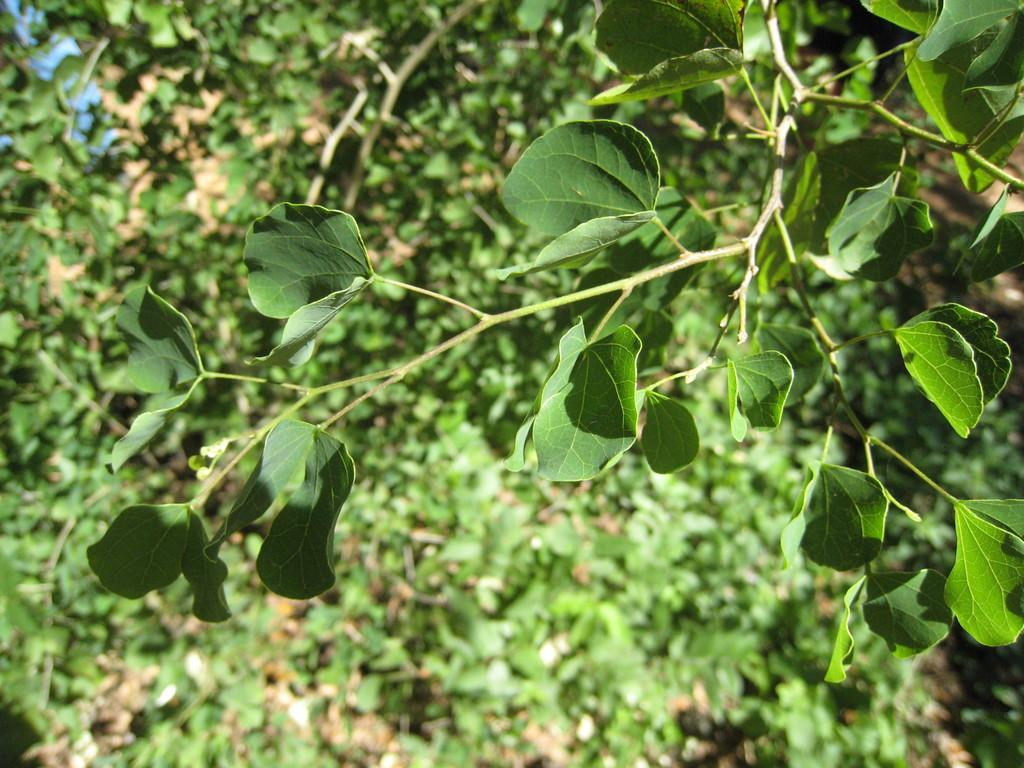Where was the image taken? The image was taken outdoors. What type of vegetation can be seen in the image? There are many trees and plants with green leaves in the image. What parts of the plants are visible in the image? There are stems and branches visible in the image. What scent can be detected from the plants in the image? The image is a photograph, so it does not have a scent. The scent of the plants cannot be detected from the image. 